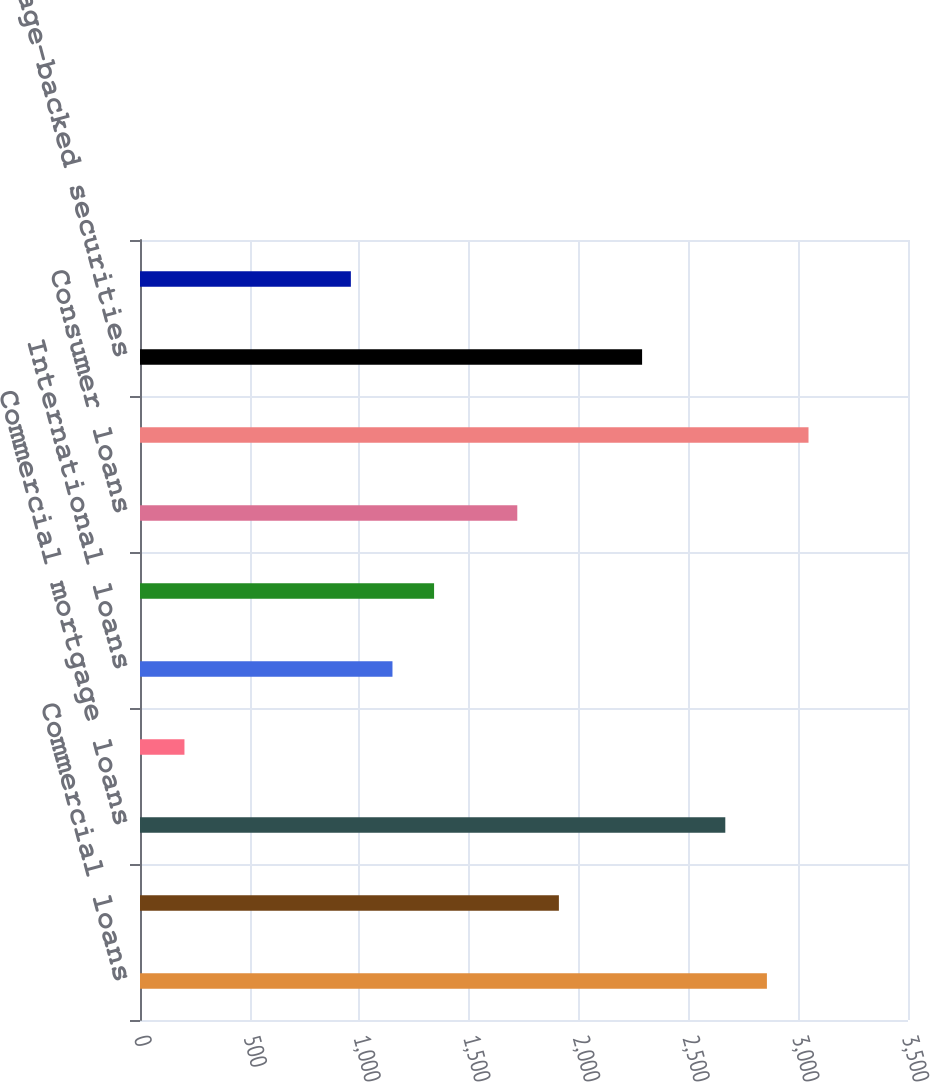<chart> <loc_0><loc_0><loc_500><loc_500><bar_chart><fcel>Commercial loans<fcel>Real estate construction loans<fcel>Commercial mortgage loans<fcel>Lease financing<fcel>International loans<fcel>Residential mortgage loans<fcel>Consumer loans<fcel>Total loans (b) (c)<fcel>Mortgage-backed securities<fcel>Other investment securities<nl><fcel>2857<fcel>1909<fcel>2667.4<fcel>202.6<fcel>1150.6<fcel>1340.2<fcel>1719.4<fcel>3046.6<fcel>2288.2<fcel>961<nl></chart> 